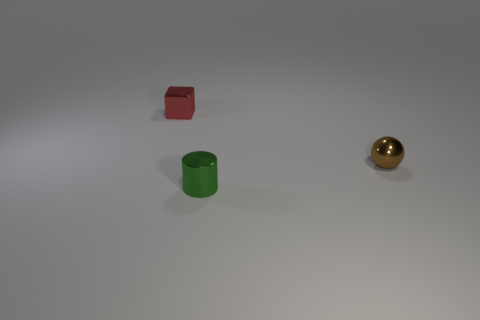Add 1 brown rubber cylinders. How many objects exist? 4 Subtract all spheres. How many objects are left? 2 Subtract all large purple matte objects. Subtract all tiny brown objects. How many objects are left? 2 Add 2 brown balls. How many brown balls are left? 3 Add 2 tiny green metallic objects. How many tiny green metallic objects exist? 3 Subtract 0 green spheres. How many objects are left? 3 